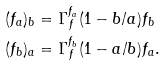Convert formula to latex. <formula><loc_0><loc_0><loc_500><loc_500>( f _ { a } ) _ { b } & = \Gamma _ { f } ^ { f _ { a } } ( 1 - b / a ) f _ { b } \\ ( f _ { b } ) _ { a } & = \Gamma _ { f } ^ { f _ { b } } ( 1 - a / b ) f _ { a } .</formula> 